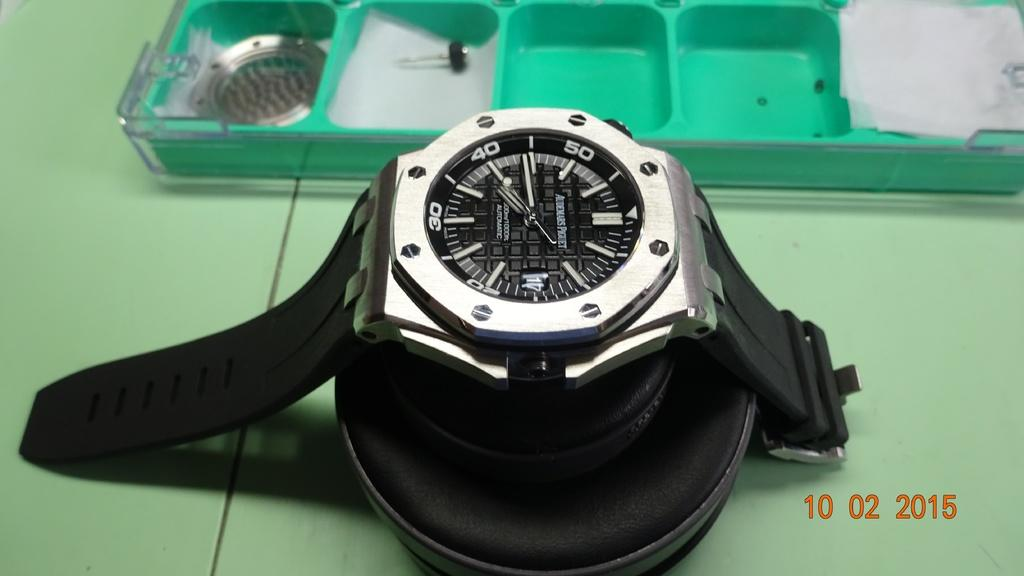<image>
Share a concise interpretation of the image provided. A black and silver watch is near some watch maintenance tools in the image from 10 02 2015. 